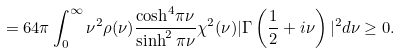Convert formula to latex. <formula><loc_0><loc_0><loc_500><loc_500>= 6 4 \pi \int _ { 0 } ^ { \infty } \nu ^ { 2 } \rho ( \nu ) \frac { { \cosh } ^ { 4 } \pi \nu } { \sinh ^ { 2 } \pi \nu } \chi ^ { 2 } ( \nu ) | \Gamma \left ( \frac { 1 } { 2 } + i \nu \right ) | ^ { 2 } d \nu \geq 0 .</formula> 